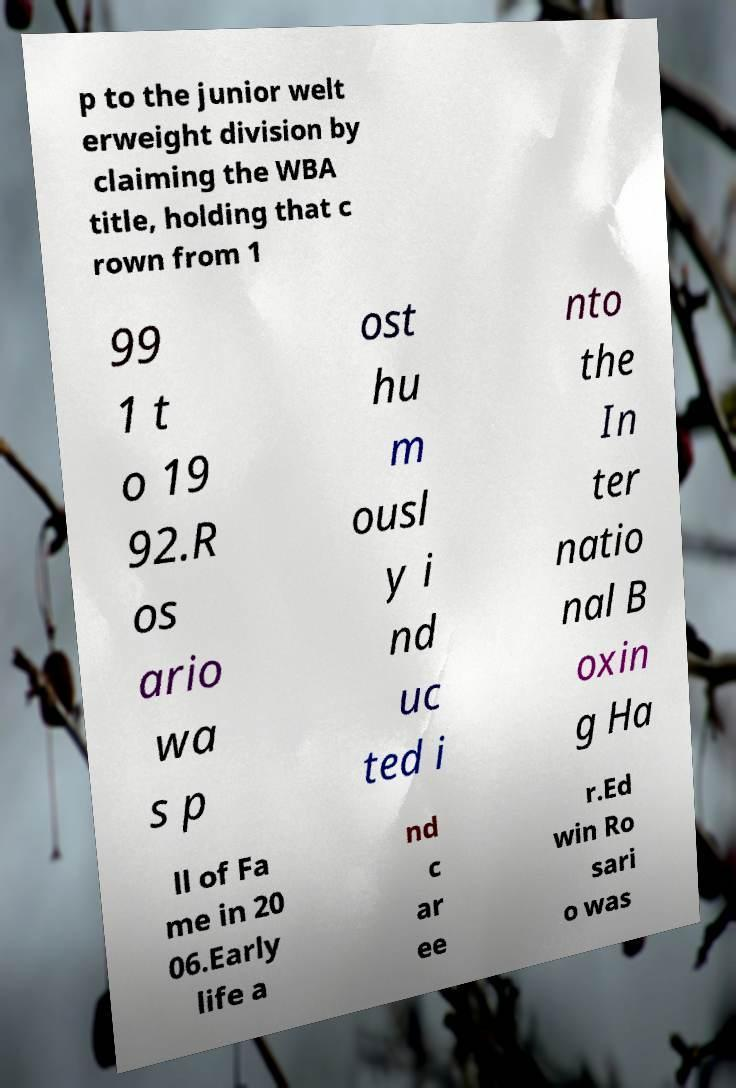Please identify and transcribe the text found in this image. p to the junior welt erweight division by claiming the WBA title, holding that c rown from 1 99 1 t o 19 92.R os ario wa s p ost hu m ousl y i nd uc ted i nto the In ter natio nal B oxin g Ha ll of Fa me in 20 06.Early life a nd c ar ee r.Ed win Ro sari o was 